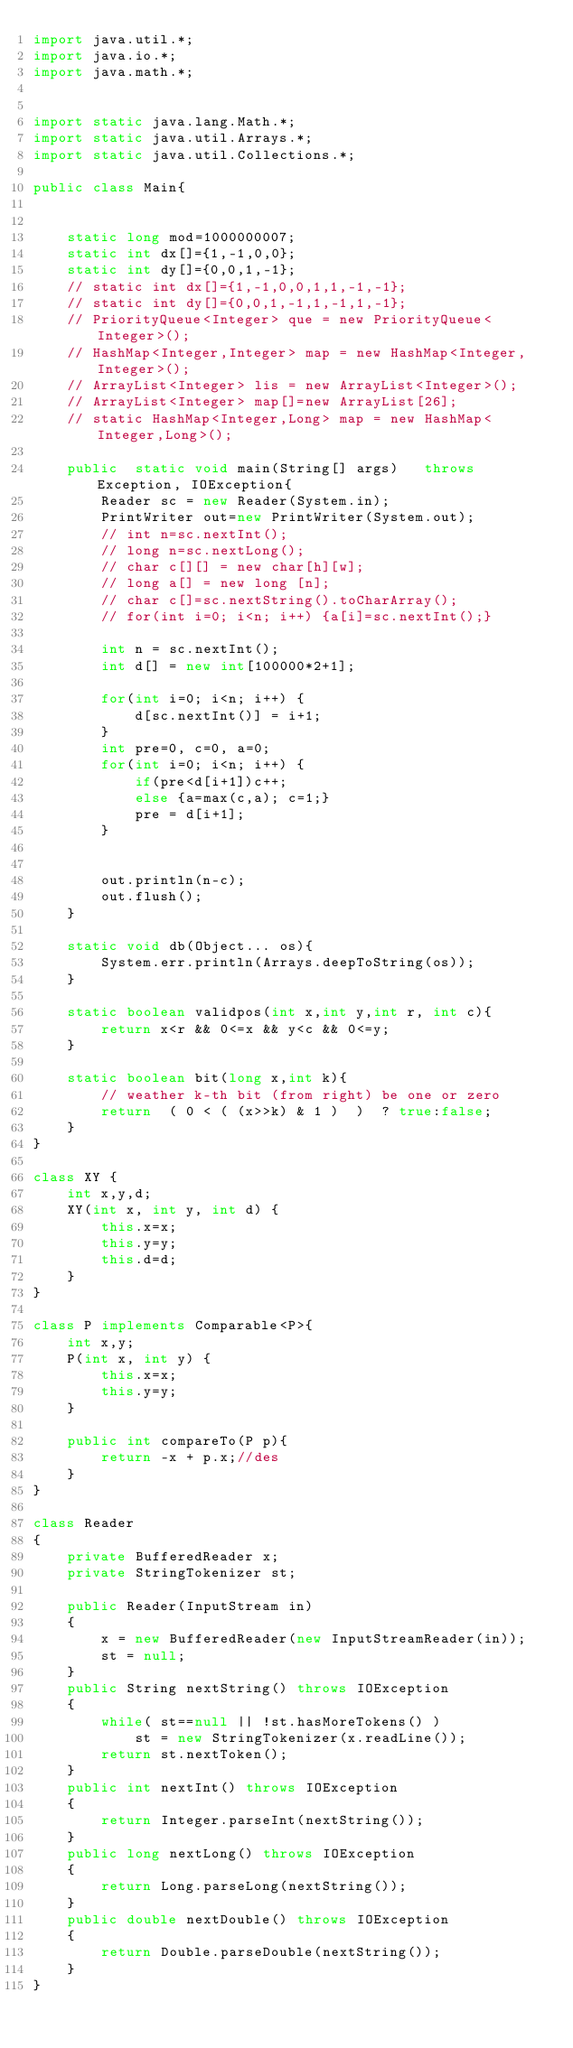Convert code to text. <code><loc_0><loc_0><loc_500><loc_500><_Java_>import java.util.*;
import java.io.*;
import java.math.*;
 
 
import static java.lang.Math.*;
import static java.util.Arrays.*;
import static java.util.Collections.*;
 
public class Main{ 
 
 
    static long mod=1000000007;
    static int dx[]={1,-1,0,0};
    static int dy[]={0,0,1,-1};
    // static int dx[]={1,-1,0,0,1,1,-1,-1};
    // static int dy[]={0,0,1,-1,1,-1,1,-1};
    // PriorityQueue<Integer> que = new PriorityQueue<Integer>(); 
    // HashMap<Integer,Integer> map = new HashMap<Integer,Integer>();
    // ArrayList<Integer> lis = new ArrayList<Integer>();
    // ArrayList<Integer> map[]=new ArrayList[26];
    // static HashMap<Integer,Long> map = new HashMap<Integer,Long>();

    public  static void main(String[] args)   throws Exception, IOException{
        Reader sc = new Reader(System.in);
        PrintWriter out=new PrintWriter(System.out);
        // int n=sc.nextInt();
        // long n=sc.nextLong();
        // char c[][] = new char[h][w];
        // long a[] = new long [n];
        // char c[]=sc.nextString().toCharArray();
        // for(int i=0; i<n; i++) {a[i]=sc.nextInt();}
        
        int n = sc.nextInt();
        int d[] = new int[100000*2+1];
        
        for(int i=0; i<n; i++) {
            d[sc.nextInt()] = i+1;
        }
        int pre=0, c=0, a=0;
        for(int i=0; i<n; i++) {
            if(pre<d[i+1])c++;
            else {a=max(c,a); c=1;}
            pre = d[i+1];
        }


        out.println(n-c);
        out.flush();
    }

    static void db(Object... os){
        System.err.println(Arrays.deepToString(os));
    }
     
    static boolean validpos(int x,int y,int r, int c){
        return x<r && 0<=x && y<c && 0<=y;
    }
     
    static boolean bit(long x,int k){
        // weather k-th bit (from right) be one or zero
        return  ( 0 < ( (x>>k) & 1 )  )  ? true:false;
    }    
}

class XY {
    int x,y,d;
    XY(int x, int y, int d) {
        this.x=x;
        this.y=y;
        this.d=d;
    } 
}
 
class P implements Comparable<P>{
    int x,y;
    P(int x, int y) {
        this.x=x;
        this.y=y;
    } 
      
    public int compareTo(P p){
        return -x + p.x;//des
    } 
}

class Reader
{ 
    private BufferedReader x;
    private StringTokenizer st;
    
    public Reader(InputStream in)
    {
        x = new BufferedReader(new InputStreamReader(in));
        st = null;
    }
    public String nextString() throws IOException
    {
        while( st==null || !st.hasMoreTokens() )
            st = new StringTokenizer(x.readLine());
        return st.nextToken();
    }
    public int nextInt() throws IOException
    {
        return Integer.parseInt(nextString());
    }
    public long nextLong() throws IOException
    {
        return Long.parseLong(nextString());
    }
    public double nextDouble() throws IOException
    {
        return Double.parseDouble(nextString());
    }
}</code> 